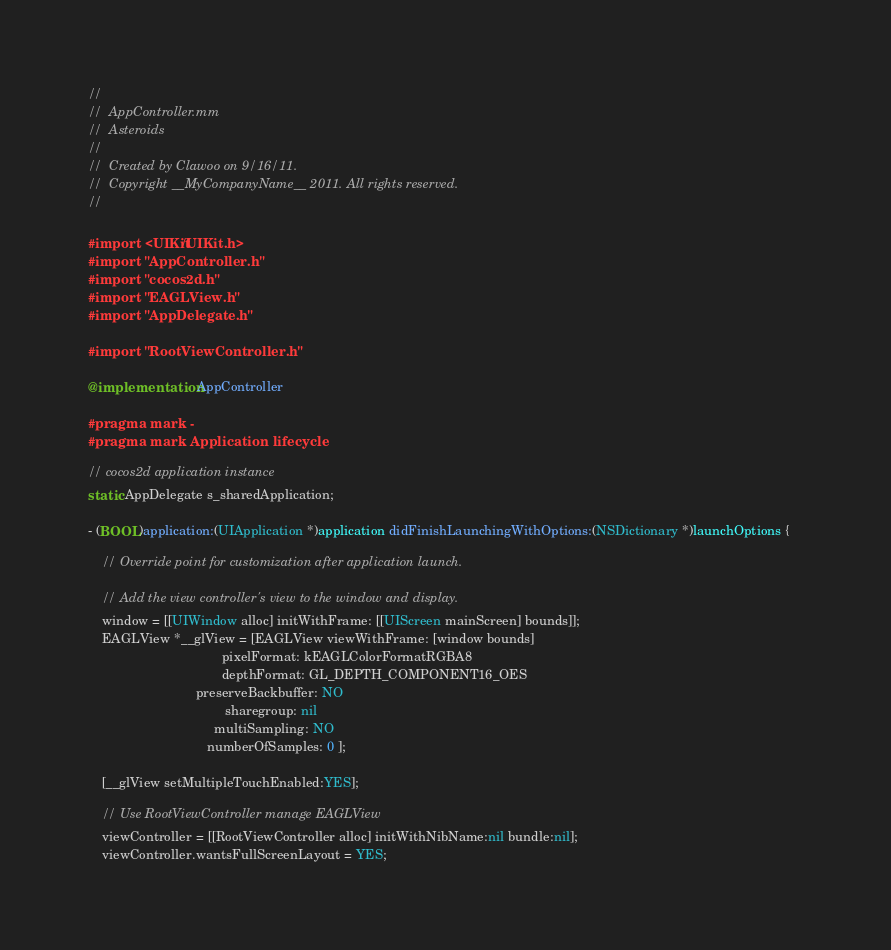Convert code to text. <code><loc_0><loc_0><loc_500><loc_500><_ObjectiveC_>//
//  AppController.mm
//  Asteroids
//
//  Created by Clawoo on 9/16/11.
//  Copyright __MyCompanyName__ 2011. All rights reserved.
//

#import <UIKit/UIKit.h>
#import "AppController.h"
#import "cocos2d.h"
#import "EAGLView.h"
#import "AppDelegate.h"

#import "RootViewController.h"

@implementation AppController

#pragma mark -
#pragma mark Application lifecycle

// cocos2d application instance
static AppDelegate s_sharedApplication;

- (BOOL)application:(UIApplication *)application didFinishLaunchingWithOptions:(NSDictionary *)launchOptions {    
    
    // Override point for customization after application launch.

    // Add the view controller's view to the window and display.
    window = [[UIWindow alloc] initWithFrame: [[UIScreen mainScreen] bounds]];
    EAGLView *__glView = [EAGLView viewWithFrame: [window bounds]
                                     pixelFormat: kEAGLColorFormatRGBA8
                                     depthFormat: GL_DEPTH_COMPONENT16_OES
                              preserveBackbuffer: NO
                                      sharegroup: nil
                                   multiSampling: NO
                                 numberOfSamples: 0 ];

    [__glView setMultipleTouchEnabled:YES];
    
    // Use RootViewController manage EAGLView 
    viewController = [[RootViewController alloc] initWithNibName:nil bundle:nil];
    viewController.wantsFullScreenLayout = YES;</code> 